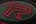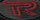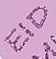What words can you see in these images in sequence, separated by a semicolon? R; R; EID 